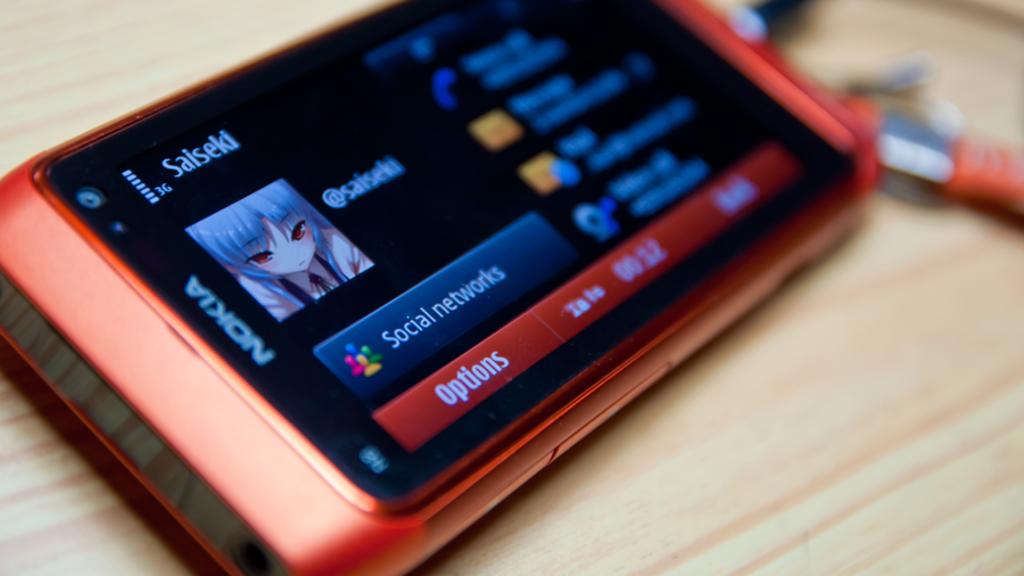Name this phone brand?
Make the answer very short. Nokia. What type of network is shown on the smartphone screen?
Your response must be concise. Social. 